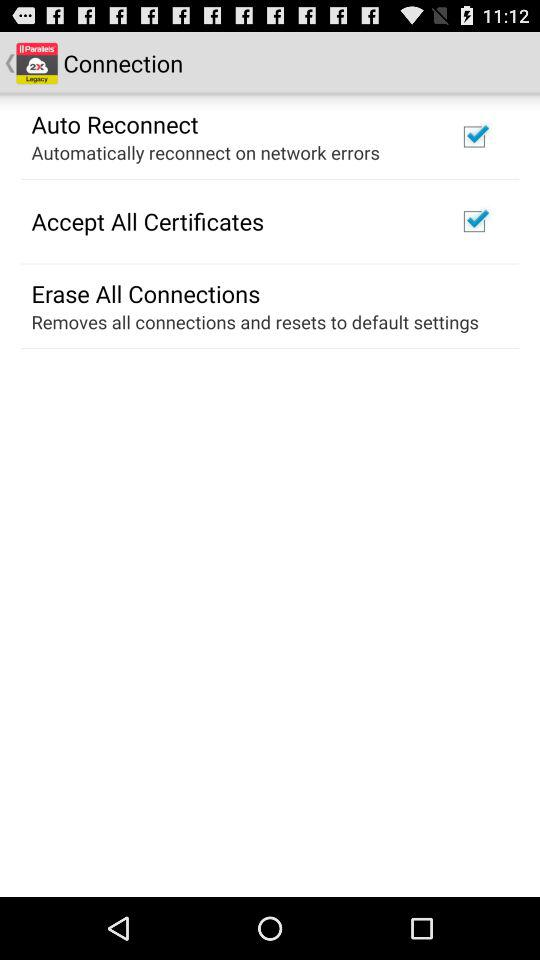What is the status of "Accept All Certificates"? The status is "on". 